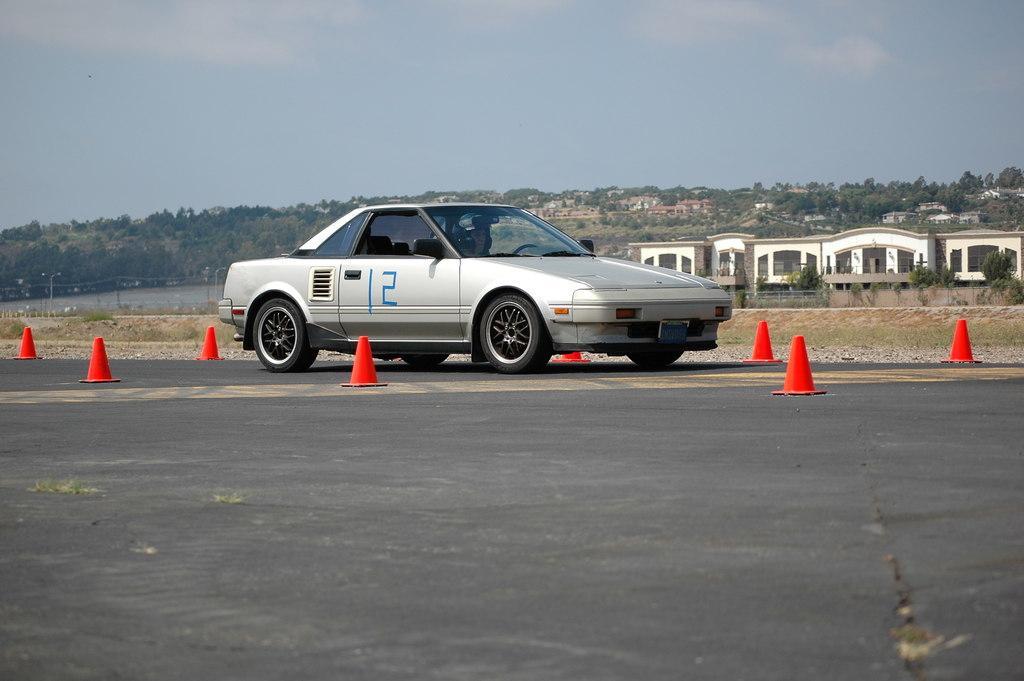Can you describe this image briefly? In this image we can see a person driving a vehicle on the road, there are some buildings, trees, traffic cones, poles and lights, in the background we can see the sky with clouds. 